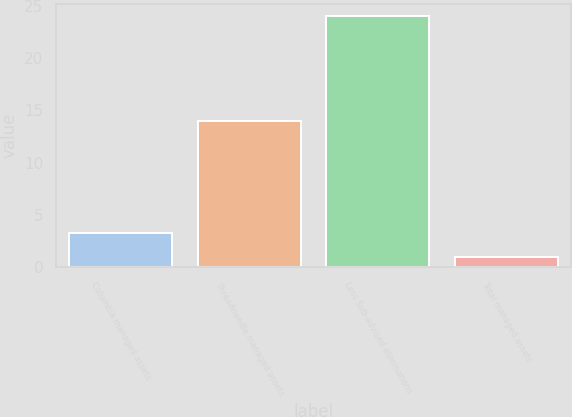Convert chart to OTSL. <chart><loc_0><loc_0><loc_500><loc_500><bar_chart><fcel>Columbia managed assets<fcel>Threadneedle managed assets<fcel>Less Sub-advised eliminations<fcel>Total managed assets<nl><fcel>3.3<fcel>14<fcel>24<fcel>1<nl></chart> 